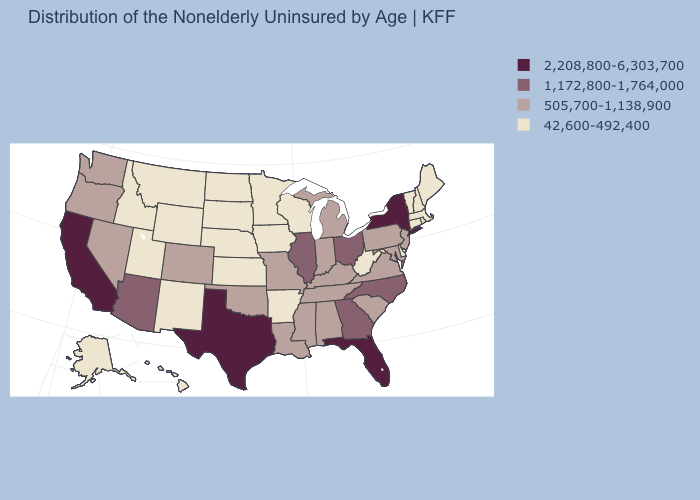Name the states that have a value in the range 42,600-492,400?
Write a very short answer. Alaska, Arkansas, Connecticut, Delaware, Hawaii, Idaho, Iowa, Kansas, Maine, Massachusetts, Minnesota, Montana, Nebraska, New Hampshire, New Mexico, North Dakota, Rhode Island, South Dakota, Utah, Vermont, West Virginia, Wisconsin, Wyoming. Which states have the highest value in the USA?
Answer briefly. California, Florida, New York, Texas. What is the value of Idaho?
Answer briefly. 42,600-492,400. Name the states that have a value in the range 505,700-1,138,900?
Concise answer only. Alabama, Colorado, Indiana, Kentucky, Louisiana, Maryland, Michigan, Mississippi, Missouri, Nevada, New Jersey, Oklahoma, Oregon, Pennsylvania, South Carolina, Tennessee, Virginia, Washington. What is the value of Colorado?
Write a very short answer. 505,700-1,138,900. Name the states that have a value in the range 2,208,800-6,303,700?
Keep it brief. California, Florida, New York, Texas. What is the value of Nebraska?
Be succinct. 42,600-492,400. Name the states that have a value in the range 505,700-1,138,900?
Quick response, please. Alabama, Colorado, Indiana, Kentucky, Louisiana, Maryland, Michigan, Mississippi, Missouri, Nevada, New Jersey, Oklahoma, Oregon, Pennsylvania, South Carolina, Tennessee, Virginia, Washington. Among the states that border Oregon , which have the highest value?
Answer briefly. California. Among the states that border Michigan , does Ohio have the lowest value?
Give a very brief answer. No. What is the value of Vermont?
Keep it brief. 42,600-492,400. Is the legend a continuous bar?
Write a very short answer. No. What is the lowest value in states that border Texas?
Be succinct. 42,600-492,400. Name the states that have a value in the range 42,600-492,400?
Answer briefly. Alaska, Arkansas, Connecticut, Delaware, Hawaii, Idaho, Iowa, Kansas, Maine, Massachusetts, Minnesota, Montana, Nebraska, New Hampshire, New Mexico, North Dakota, Rhode Island, South Dakota, Utah, Vermont, West Virginia, Wisconsin, Wyoming. Name the states that have a value in the range 42,600-492,400?
Be succinct. Alaska, Arkansas, Connecticut, Delaware, Hawaii, Idaho, Iowa, Kansas, Maine, Massachusetts, Minnesota, Montana, Nebraska, New Hampshire, New Mexico, North Dakota, Rhode Island, South Dakota, Utah, Vermont, West Virginia, Wisconsin, Wyoming. 